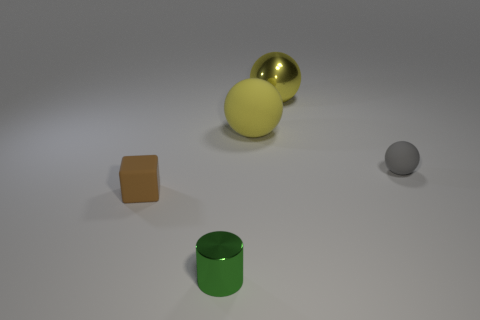Is the number of brown rubber objects less than the number of large spheres?
Make the answer very short. Yes. What is the material of the brown thing that is the same size as the shiny cylinder?
Your answer should be very brief. Rubber. Is the color of the tiny rubber ball the same as the rubber thing left of the tiny cylinder?
Offer a terse response. No. Are there fewer yellow metal balls that are in front of the cylinder than big gray rubber cylinders?
Make the answer very short. No. How many big cyan cylinders are there?
Make the answer very short. 0. What shape is the metallic thing behind the metal object that is in front of the gray rubber ball?
Make the answer very short. Sphere. There is a brown rubber block; what number of small green things are behind it?
Your answer should be very brief. 0. Do the small brown cube and the big sphere behind the yellow rubber thing have the same material?
Provide a short and direct response. No. Is there a green rubber cube that has the same size as the brown matte block?
Your response must be concise. No. Are there the same number of tiny green metallic cylinders behind the yellow matte thing and small matte things?
Keep it short and to the point. No. 